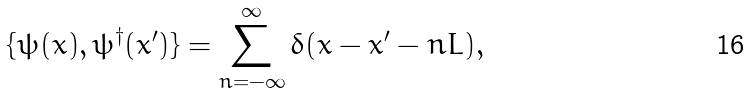Convert formula to latex. <formula><loc_0><loc_0><loc_500><loc_500>\{ \psi ( x ) , \psi ^ { \dagger } ( x ^ { \prime } ) \} = \sum _ { n = - \infty } ^ { \infty } \delta ( x - x ^ { \prime } - n L ) ,</formula> 